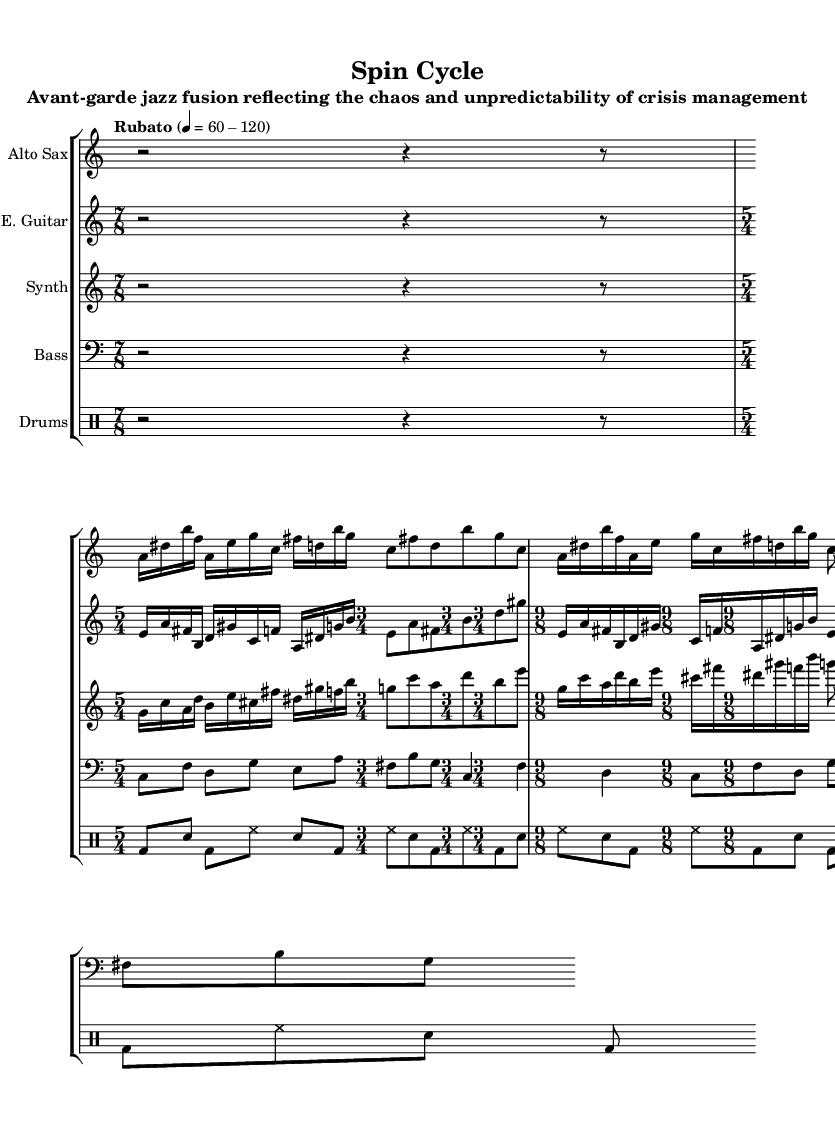What is the tempo marking of this piece? The tempo marking indicates that the piece should be played rubato, with a tempo range of 60 to 120 beats per minute. This range is specified in the global variable section of the code.
Answer: Rubato 60-120 What are the time signatures used in the saxophone part? The saxophone part features a sequence of time signatures: 7/8, 5/4, 3/4, and 9/8. Each is explicitly set in the music notation provided in the code.
Answer: 7/8, 5/4, 3/4, 9/8 How many measures are present in the guitar part? The guitar part has four distinct sections, each with a different time signature. The number of measures can be counted: one measure each for the 7/8, 5/4, and 3/4 sections, and one for the 9/8. Thus, there are four measures total.
Answer: 4 What is the note value of the longest note in the drums section? Analyzing the drums section, the longest note is a bass drum note which occurs as a quarter note. This is evident in the context of the measures specified, particularly within the sections featuring eighth notes and quarter notes.
Answer: Quarter note Which instrument plays the highest pitch in the combined score? By comparing the highest written pitches across the different instruments, the alto saxophone plays the highest pitch, reaching a high b in the second measure of the 5/4 section. This can be identified by visually scanning the notes in each staff.
Answer: Alto Sax 